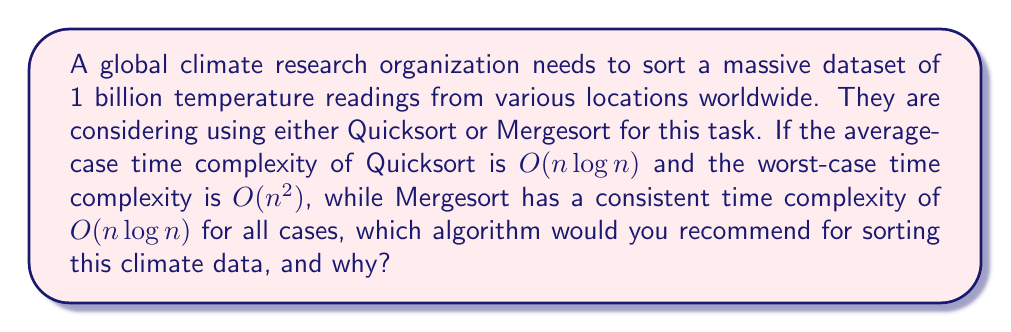What is the answer to this math problem? To answer this question, we need to consider the time complexity of both algorithms and the size of the dataset:

1. Dataset size: $n = 1,000,000,000$ (1 billion) temperature readings

2. Quicksort:
   - Average-case: $O(n \log n)$
   - Worst-case: $O(n^2)$

3. Mergesort:
   - All cases: $O(n \log n)$

Let's compare the algorithms:

a) Quicksort (average-case) vs. Mergesort:
   Both have the same time complexity of $O(n \log n)$, so they would perform similarly in the average case.

b) Quicksort (worst-case) vs. Mergesort:
   Quicksort: $O(n^2) = O((10^9)^2) = O(10^{18})$
   Mergesort: $O(n \log n) = O(10^9 \log 10^9) \approx O(10^9 \cdot 30) = O(3 \times 10^{10})$

In the worst-case scenario, Quicksort would be significantly slower than Mergesort.

Considering the large dataset size and the potential impact of worst-case scenarios in climate data (which might have patterns or partially sorted sequences), Mergesort would be the recommended choice for the following reasons:

1. Consistent performance: Mergesort guarantees $O(n \log n)$ time complexity in all cases, providing predictable performance.
2. Stability: Mergesort is a stable sorting algorithm, which can be beneficial when dealing with complex climate data that may have multiple attributes.
3. Risk mitigation: Using Mergesort eliminates the risk of encountering the worst-case scenario of Quicksort, which could significantly slow down the sorting process for such a large dataset.

While Quicksort might perform well in practice due to its good average-case performance and cache-friendly behavior, the potential risk of worst-case scenarios with such a large and critical dataset makes Mergesort a safer and more reliable choice for sorting global climate data.
Answer: Mergesort is the recommended algorithm for sorting the global climate data due to its consistent $O(n \log n)$ time complexity in all cases, stability, and elimination of the risk of encountering Quicksort's worst-case scenario, which could significantly impact the processing time for such a large dataset. 